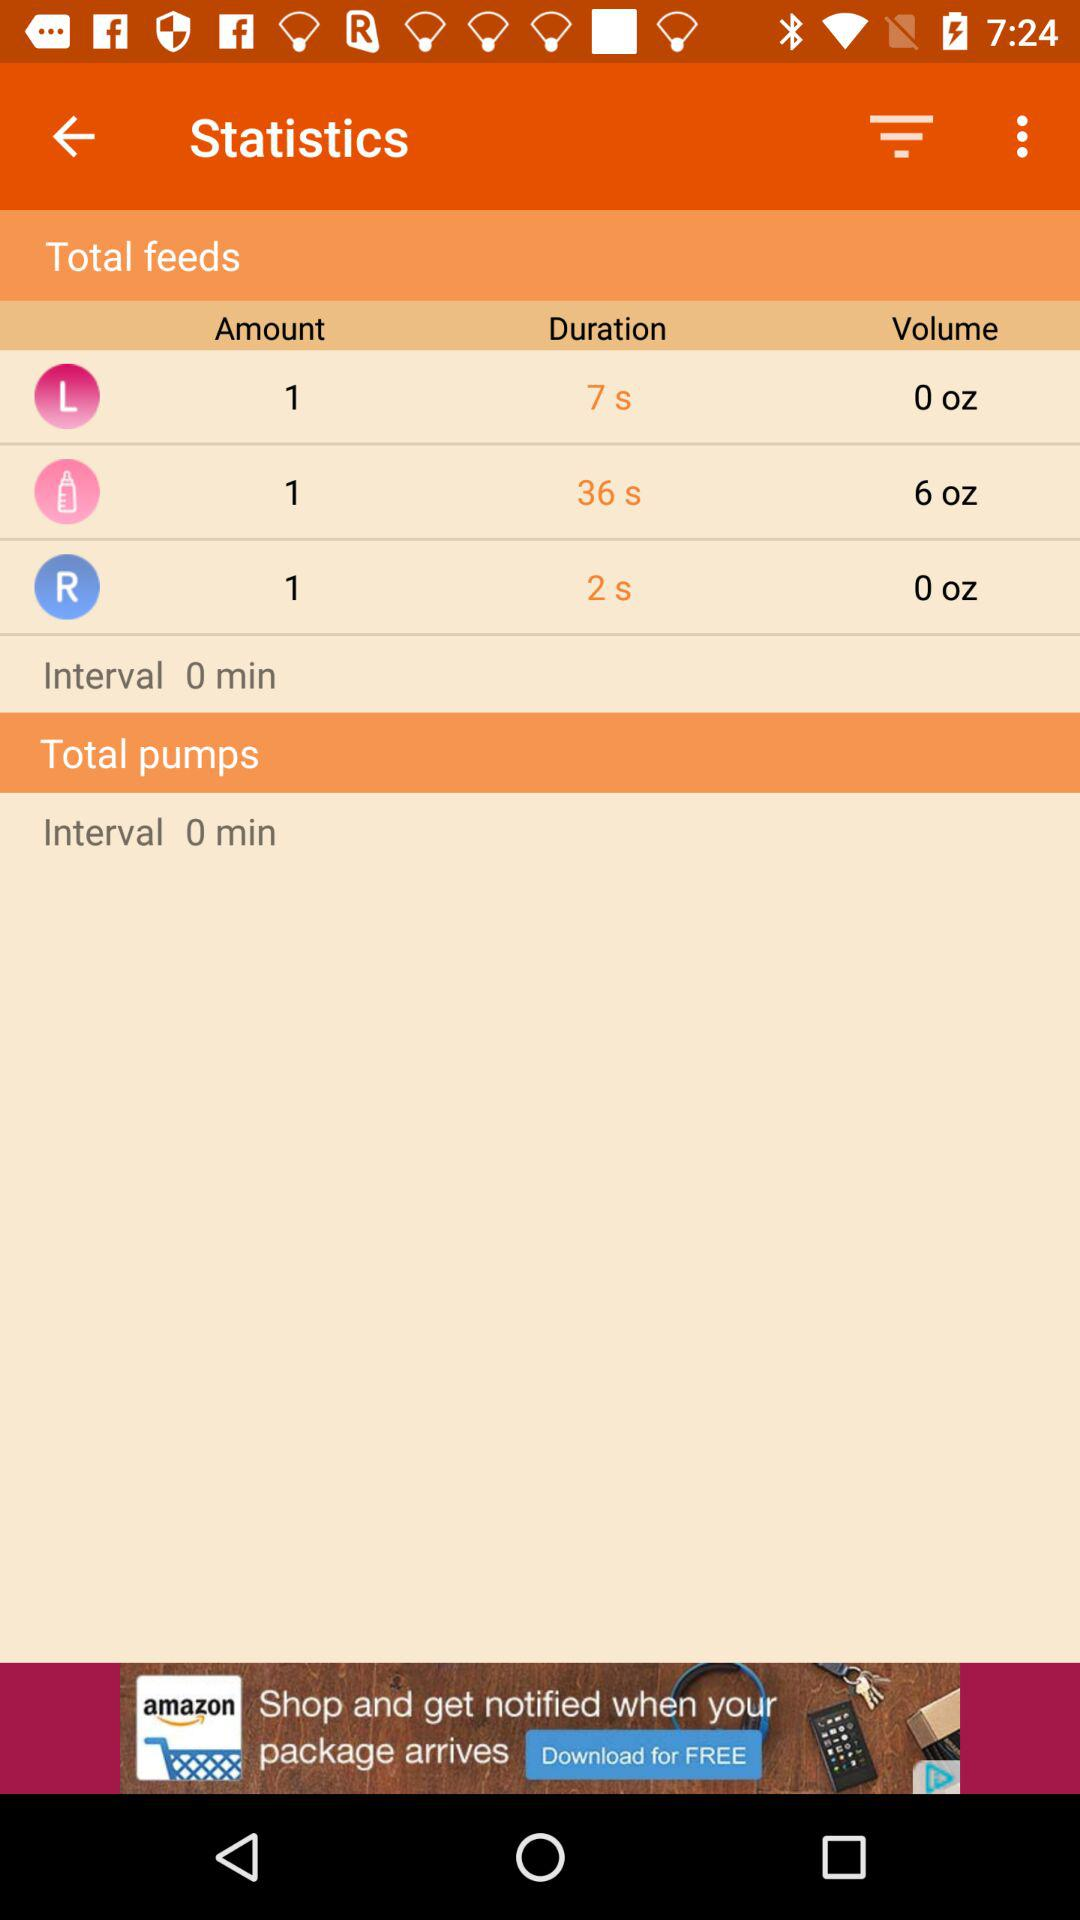What is the application name in the advertisement? The application name in the advertisement is "amazon". 